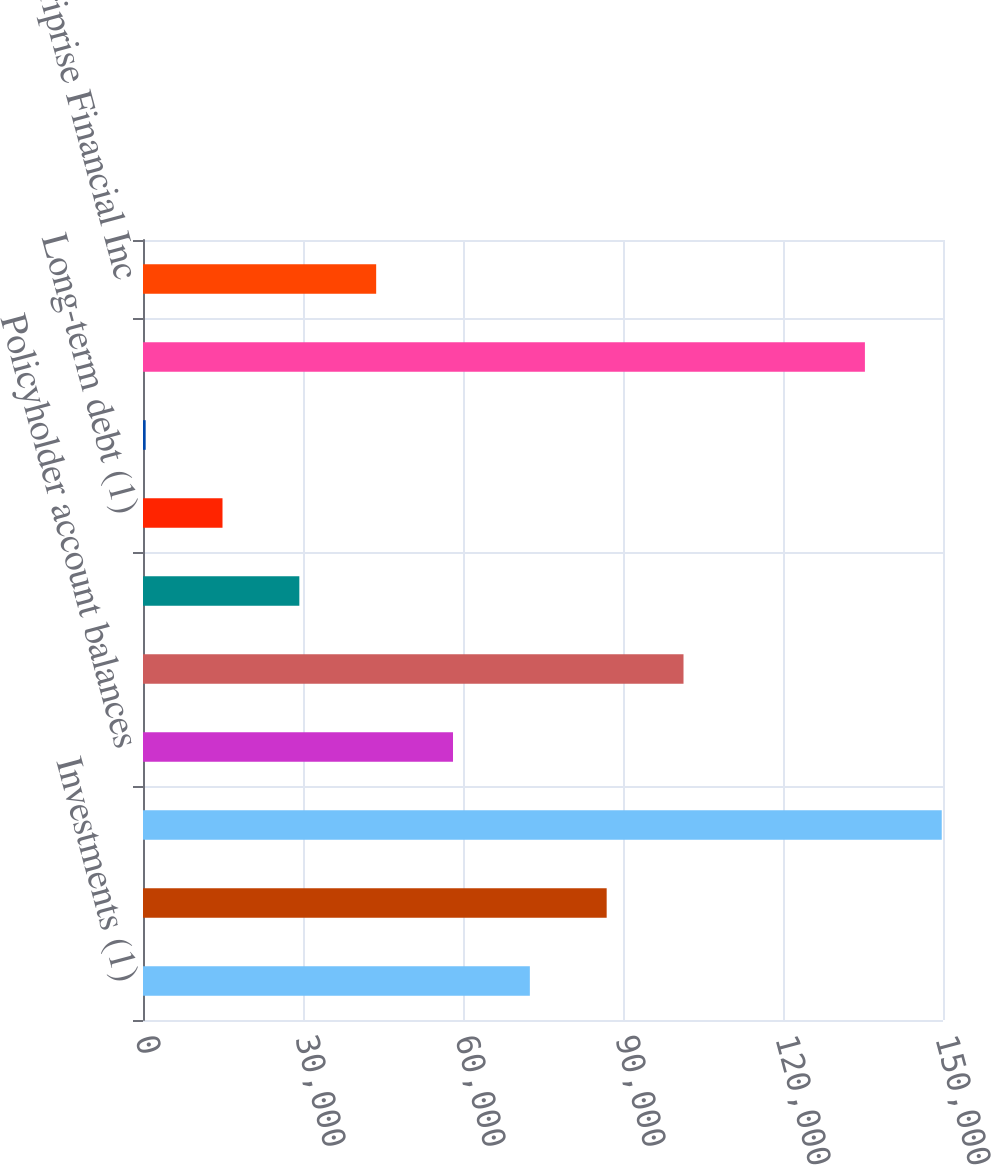<chart> <loc_0><loc_0><loc_500><loc_500><bar_chart><fcel>Investments (1)<fcel>Separate account assets<fcel>Total assets<fcel>Policyholder account balances<fcel>Separate account liabilities<fcel>Customer deposits<fcel>Long-term debt (1)<fcel>Short-term borrowings<fcel>Total liabilities<fcel>Total Ameriprise Financial Inc<nl><fcel>72532.5<fcel>86939<fcel>149766<fcel>58126<fcel>101346<fcel>29313<fcel>14906.5<fcel>500<fcel>135359<fcel>43719.5<nl></chart> 